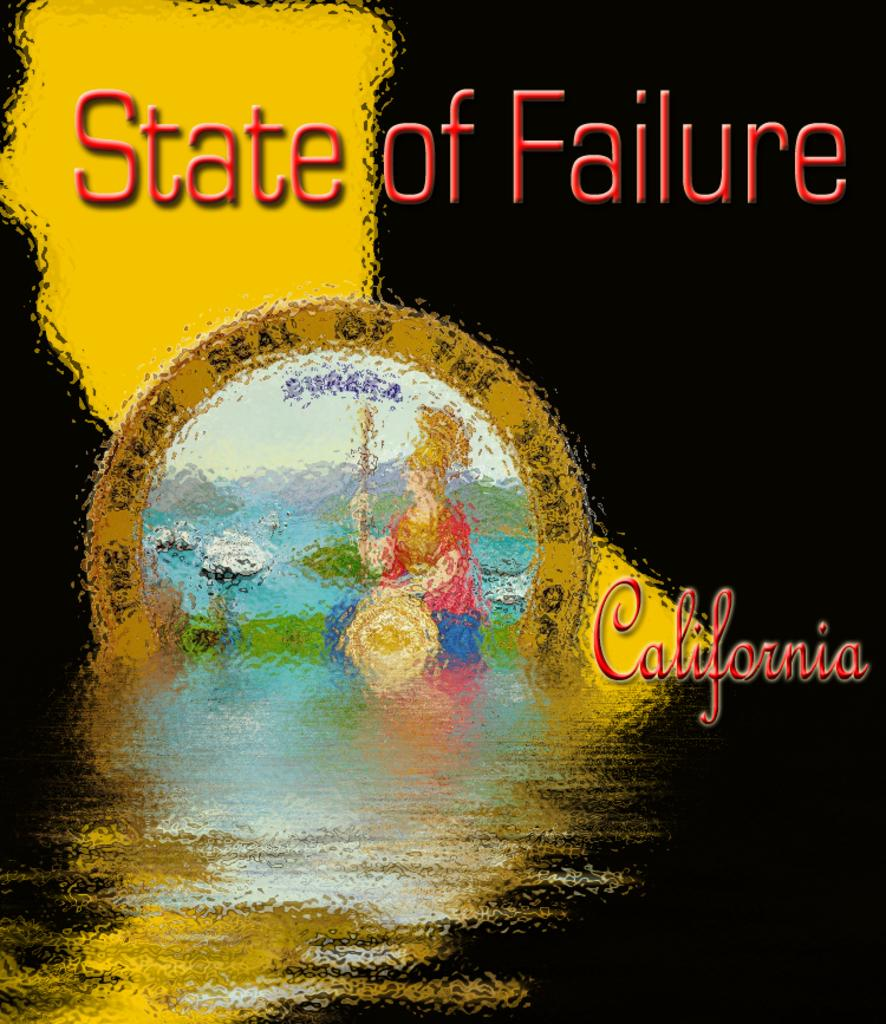Provide a one-sentence caption for the provided image. The cover of State of Failure with a lady and some flowers. 